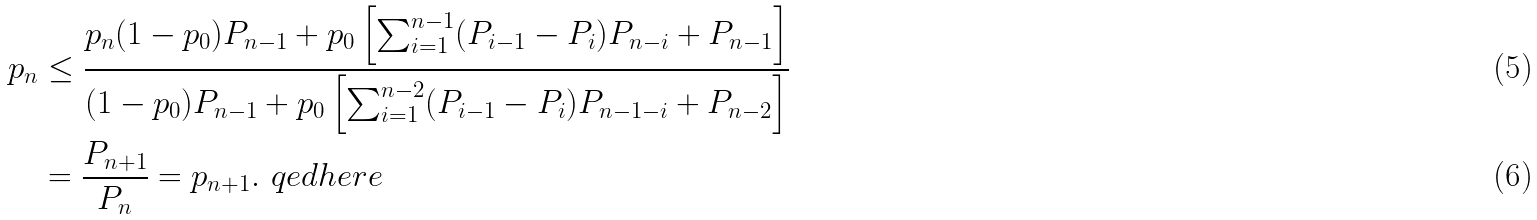Convert formula to latex. <formula><loc_0><loc_0><loc_500><loc_500>p _ { n } & \leq \frac { p _ { n } ( 1 - p _ { 0 } ) P _ { n - 1 } + p _ { 0 } \left [ \sum _ { i = 1 } ^ { n - 1 } ( P _ { i - 1 } - P _ { i } ) P _ { n - i } + P _ { n - 1 } \right ] } { ( 1 - p _ { 0 } ) P _ { n - 1 } + p _ { 0 } \left [ \sum _ { i = 1 } ^ { n - 2 } ( P _ { i - 1 } - P _ { i } ) P _ { n - 1 - i } + P _ { n - 2 } \right ] } \\ & = \frac { P _ { n + 1 } } { P _ { n } } = p _ { n + 1 } . \ q e d h e r e</formula> 